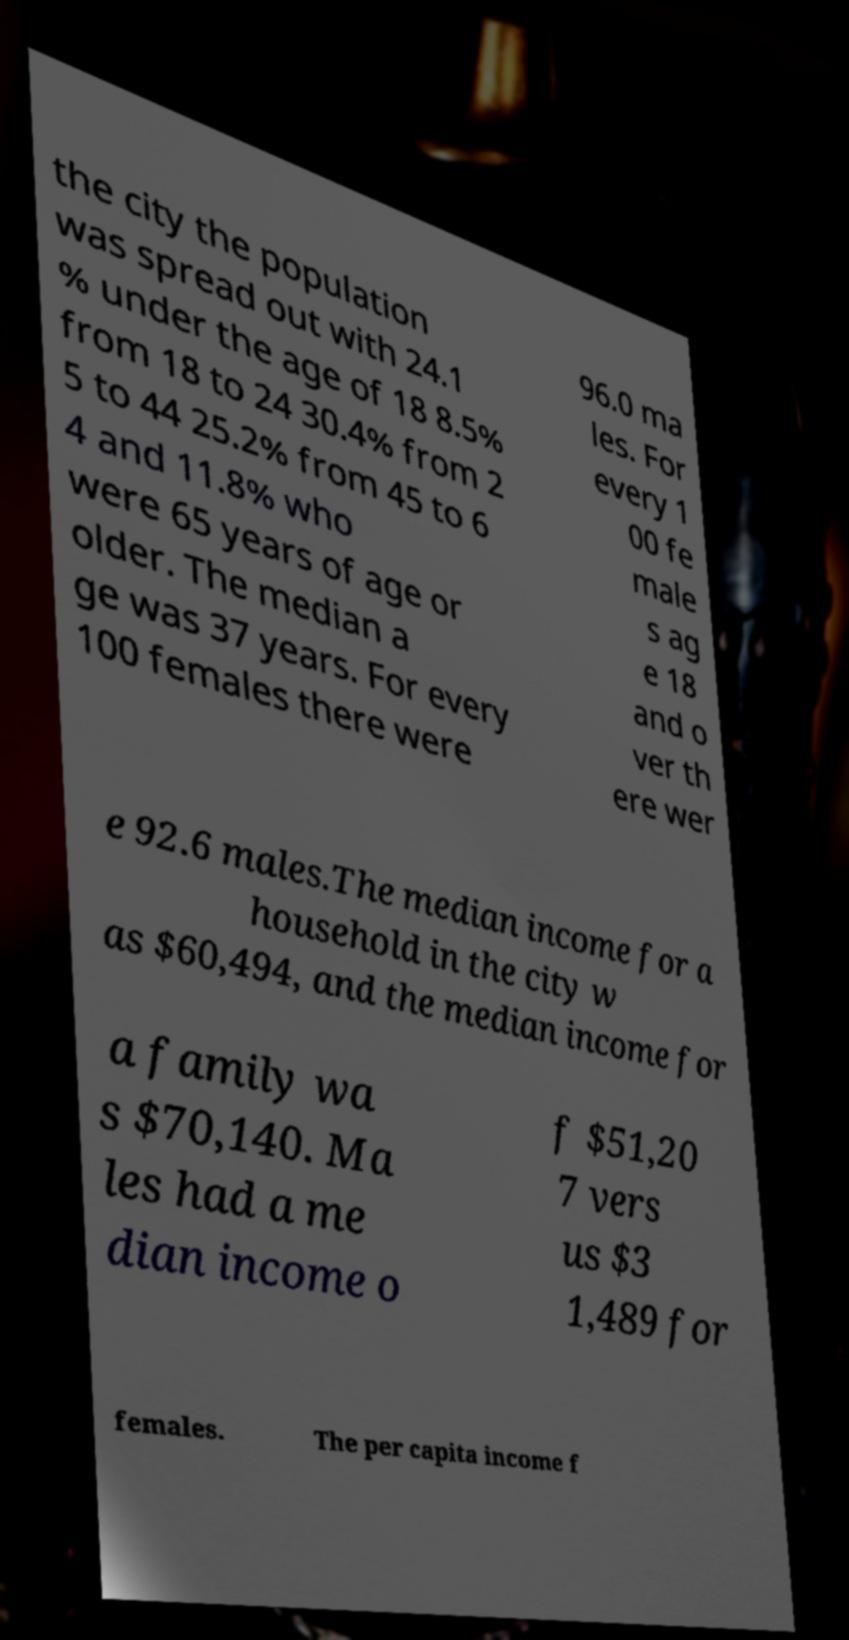For documentation purposes, I need the text within this image transcribed. Could you provide that? the city the population was spread out with 24.1 % under the age of 18 8.5% from 18 to 24 30.4% from 2 5 to 44 25.2% from 45 to 6 4 and 11.8% who were 65 years of age or older. The median a ge was 37 years. For every 100 females there were 96.0 ma les. For every 1 00 fe male s ag e 18 and o ver th ere wer e 92.6 males.The median income for a household in the city w as $60,494, and the median income for a family wa s $70,140. Ma les had a me dian income o f $51,20 7 vers us $3 1,489 for females. The per capita income f 